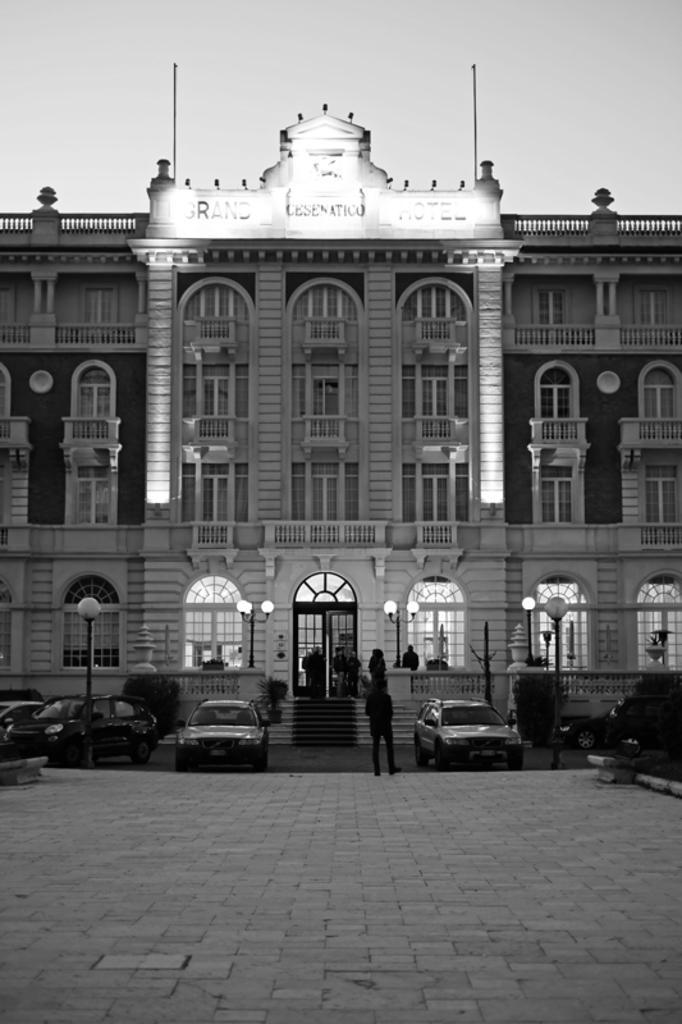Could you give a brief overview of what you see in this image? In this image we can see a building with a signboard, windows, staircase and a door. We can also see some plants, cars parked aside, a group of people and some street lamps. On the backside we can see the sky. 